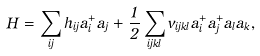<formula> <loc_0><loc_0><loc_500><loc_500>H = \sum _ { i j } h _ { i j } a _ { i } ^ { + } a _ { j } + \frac { 1 } { 2 } \sum _ { i j k l } v _ { i j k l } a ^ { + } _ { i } a ^ { + } _ { j } a _ { l } a _ { k } ,</formula> 